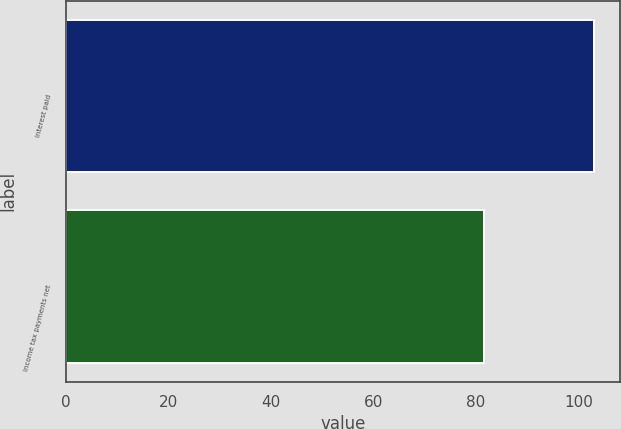Convert chart. <chart><loc_0><loc_0><loc_500><loc_500><bar_chart><fcel>Interest paid<fcel>Income tax payments net<nl><fcel>103<fcel>81.5<nl></chart> 